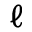Convert formula to latex. <formula><loc_0><loc_0><loc_500><loc_500>\ell</formula> 